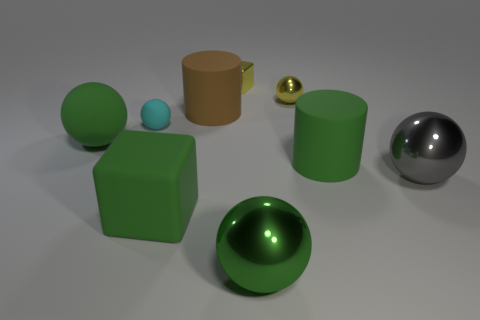There is a green object behind the rubber object right of the green object in front of the matte cube; what is its material?
Give a very brief answer. Rubber. What number of purple things are rubber objects or small things?
Your answer should be compact. 0. There is a yellow cube that is to the right of the object that is to the left of the rubber ball that is right of the large green matte ball; how big is it?
Give a very brief answer. Small. The green rubber object that is the same shape as the brown matte object is what size?
Your answer should be compact. Large. What number of small objects are gray shiny spheres or matte cubes?
Provide a short and direct response. 0. Do the big green ball that is right of the brown rubber cylinder and the yellow block that is on the right side of the cyan rubber object have the same material?
Your answer should be very brief. Yes. What is the large green sphere that is behind the large gray sphere made of?
Ensure brevity in your answer.  Rubber. What number of matte objects are small blue things or small yellow objects?
Provide a short and direct response. 0. What is the color of the small sphere on the right side of the matte block that is in front of the tiny rubber sphere?
Offer a terse response. Yellow. Is the yellow sphere made of the same material as the tiny thing to the left of the big green cube?
Provide a succinct answer. No. 